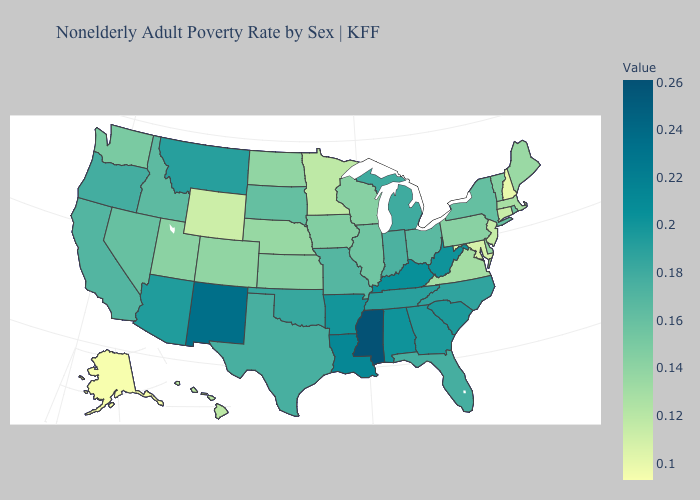Which states have the highest value in the USA?
Quick response, please. Mississippi. Among the states that border New Jersey , does Pennsylvania have the highest value?
Concise answer only. No. Among the states that border Kansas , which have the highest value?
Quick response, please. Oklahoma. Which states have the lowest value in the USA?
Answer briefly. Alaska. Is the legend a continuous bar?
Keep it brief. Yes. Does New Jersey have the highest value in the USA?
Give a very brief answer. No. 